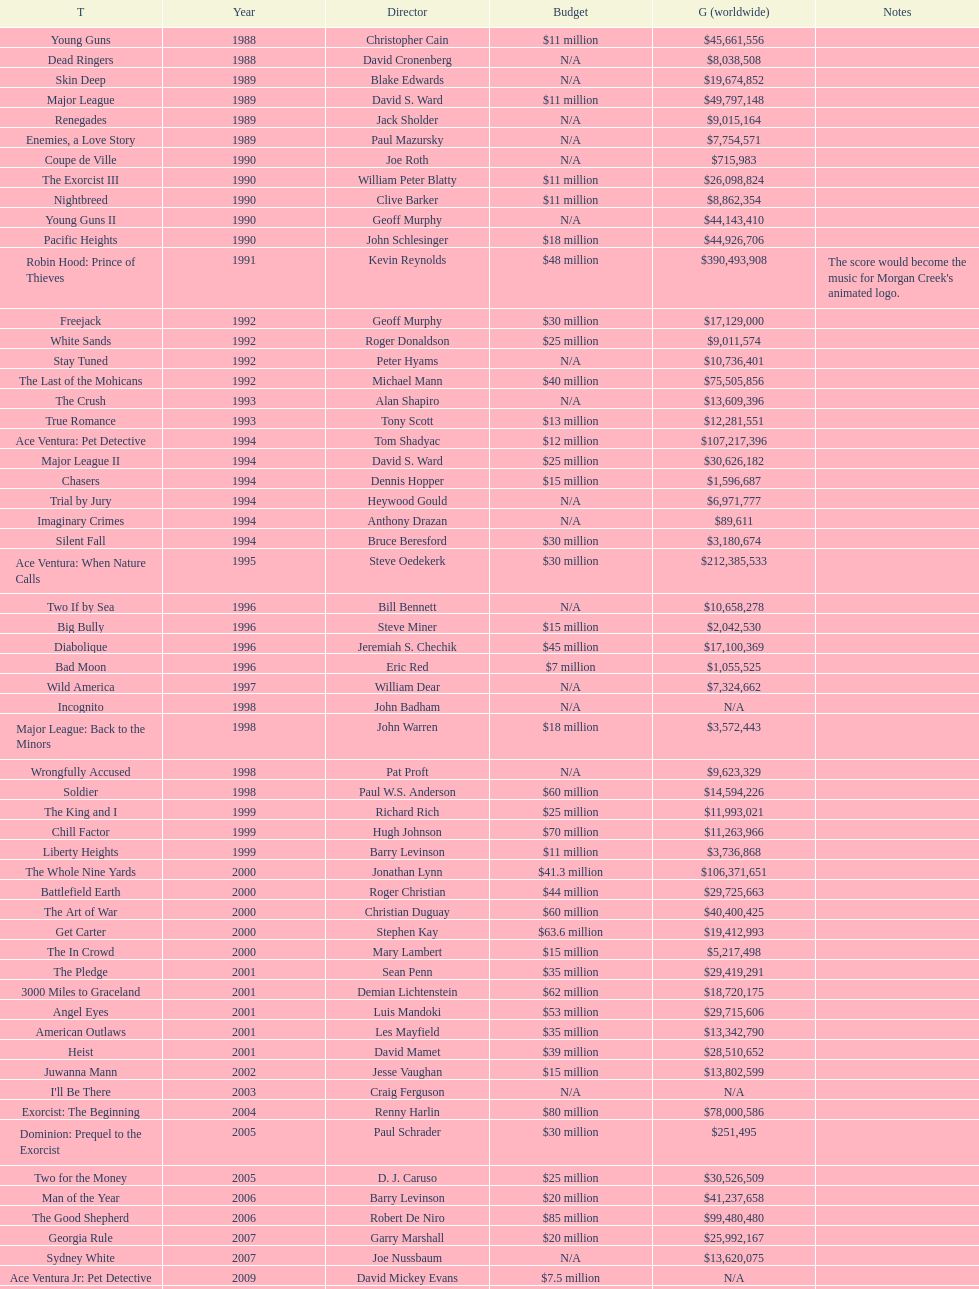Can you give me this table as a dict? {'header': ['T', 'Year', 'Director', 'Budget', 'G (worldwide)', 'Notes'], 'rows': [['Young Guns', '1988', 'Christopher Cain', '$11 million', '$45,661,556', ''], ['Dead Ringers', '1988', 'David Cronenberg', 'N/A', '$8,038,508', ''], ['Skin Deep', '1989', 'Blake Edwards', 'N/A', '$19,674,852', ''], ['Major League', '1989', 'David S. Ward', '$11 million', '$49,797,148', ''], ['Renegades', '1989', 'Jack Sholder', 'N/A', '$9,015,164', ''], ['Enemies, a Love Story', '1989', 'Paul Mazursky', 'N/A', '$7,754,571', ''], ['Coupe de Ville', '1990', 'Joe Roth', 'N/A', '$715,983', ''], ['The Exorcist III', '1990', 'William Peter Blatty', '$11 million', '$26,098,824', ''], ['Nightbreed', '1990', 'Clive Barker', '$11 million', '$8,862,354', ''], ['Young Guns II', '1990', 'Geoff Murphy', 'N/A', '$44,143,410', ''], ['Pacific Heights', '1990', 'John Schlesinger', '$18 million', '$44,926,706', ''], ['Robin Hood: Prince of Thieves', '1991', 'Kevin Reynolds', '$48 million', '$390,493,908', "The score would become the music for Morgan Creek's animated logo."], ['Freejack', '1992', 'Geoff Murphy', '$30 million', '$17,129,000', ''], ['White Sands', '1992', 'Roger Donaldson', '$25 million', '$9,011,574', ''], ['Stay Tuned', '1992', 'Peter Hyams', 'N/A', '$10,736,401', ''], ['The Last of the Mohicans', '1992', 'Michael Mann', '$40 million', '$75,505,856', ''], ['The Crush', '1993', 'Alan Shapiro', 'N/A', '$13,609,396', ''], ['True Romance', '1993', 'Tony Scott', '$13 million', '$12,281,551', ''], ['Ace Ventura: Pet Detective', '1994', 'Tom Shadyac', '$12 million', '$107,217,396', ''], ['Major League II', '1994', 'David S. Ward', '$25 million', '$30,626,182', ''], ['Chasers', '1994', 'Dennis Hopper', '$15 million', '$1,596,687', ''], ['Trial by Jury', '1994', 'Heywood Gould', 'N/A', '$6,971,777', ''], ['Imaginary Crimes', '1994', 'Anthony Drazan', 'N/A', '$89,611', ''], ['Silent Fall', '1994', 'Bruce Beresford', '$30 million', '$3,180,674', ''], ['Ace Ventura: When Nature Calls', '1995', 'Steve Oedekerk', '$30 million', '$212,385,533', ''], ['Two If by Sea', '1996', 'Bill Bennett', 'N/A', '$10,658,278', ''], ['Big Bully', '1996', 'Steve Miner', '$15 million', '$2,042,530', ''], ['Diabolique', '1996', 'Jeremiah S. Chechik', '$45 million', '$17,100,369', ''], ['Bad Moon', '1996', 'Eric Red', '$7 million', '$1,055,525', ''], ['Wild America', '1997', 'William Dear', 'N/A', '$7,324,662', ''], ['Incognito', '1998', 'John Badham', 'N/A', 'N/A', ''], ['Major League: Back to the Minors', '1998', 'John Warren', '$18 million', '$3,572,443', ''], ['Wrongfully Accused', '1998', 'Pat Proft', 'N/A', '$9,623,329', ''], ['Soldier', '1998', 'Paul W.S. Anderson', '$60 million', '$14,594,226', ''], ['The King and I', '1999', 'Richard Rich', '$25 million', '$11,993,021', ''], ['Chill Factor', '1999', 'Hugh Johnson', '$70 million', '$11,263,966', ''], ['Liberty Heights', '1999', 'Barry Levinson', '$11 million', '$3,736,868', ''], ['The Whole Nine Yards', '2000', 'Jonathan Lynn', '$41.3 million', '$106,371,651', ''], ['Battlefield Earth', '2000', 'Roger Christian', '$44 million', '$29,725,663', ''], ['The Art of War', '2000', 'Christian Duguay', '$60 million', '$40,400,425', ''], ['Get Carter', '2000', 'Stephen Kay', '$63.6 million', '$19,412,993', ''], ['The In Crowd', '2000', 'Mary Lambert', '$15 million', '$5,217,498', ''], ['The Pledge', '2001', 'Sean Penn', '$35 million', '$29,419,291', ''], ['3000 Miles to Graceland', '2001', 'Demian Lichtenstein', '$62 million', '$18,720,175', ''], ['Angel Eyes', '2001', 'Luis Mandoki', '$53 million', '$29,715,606', ''], ['American Outlaws', '2001', 'Les Mayfield', '$35 million', '$13,342,790', ''], ['Heist', '2001', 'David Mamet', '$39 million', '$28,510,652', ''], ['Juwanna Mann', '2002', 'Jesse Vaughan', '$15 million', '$13,802,599', ''], ["I'll Be There", '2003', 'Craig Ferguson', 'N/A', 'N/A', ''], ['Exorcist: The Beginning', '2004', 'Renny Harlin', '$80 million', '$78,000,586', ''], ['Dominion: Prequel to the Exorcist', '2005', 'Paul Schrader', '$30 million', '$251,495', ''], ['Two for the Money', '2005', 'D. J. Caruso', '$25 million', '$30,526,509', ''], ['Man of the Year', '2006', 'Barry Levinson', '$20 million', '$41,237,658', ''], ['The Good Shepherd', '2006', 'Robert De Niro', '$85 million', '$99,480,480', ''], ['Georgia Rule', '2007', 'Garry Marshall', '$20 million', '$25,992,167', ''], ['Sydney White', '2007', 'Joe Nussbaum', 'N/A', '$13,620,075', ''], ['Ace Ventura Jr: Pet Detective', '2009', 'David Mickey Evans', '$7.5 million', 'N/A', ''], ['Dream House', '2011', 'Jim Sheridan', '$50 million', '$38,502,340', ''], ['The Thing', '2011', 'Matthijs van Heijningen Jr.', '$38 million', '$27,428,670', ''], ['Tupac', '2014', 'Antoine Fuqua', '$45 million', '', '']]} Did true romance make more or less money than diabolique? Less. 